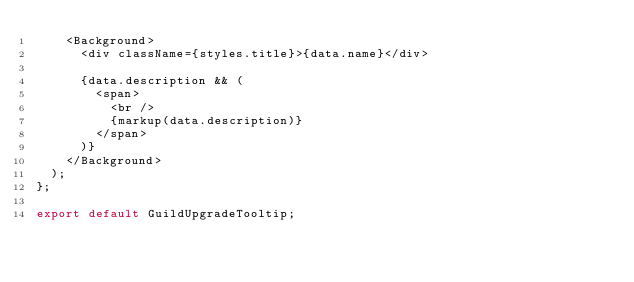Convert code to text. <code><loc_0><loc_0><loc_500><loc_500><_JavaScript_>    <Background>
      <div className={styles.title}>{data.name}</div>

      {data.description && (
        <span>
          <br />
          {markup(data.description)}
        </span>
      )}
    </Background>
  );
};

export default GuildUpgradeTooltip;
</code> 